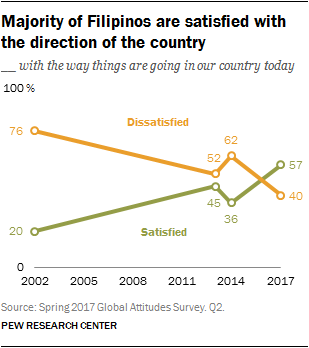Mention a couple of crucial points in this snapshot. The median of the orange graph is equal to the rightmost value of the green graph. The value of "Satisfied dot line 45" in 2017 was not present. 